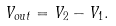<formula> <loc_0><loc_0><loc_500><loc_500>V _ { o u t } = V _ { 2 } - V _ { 1 } .</formula> 